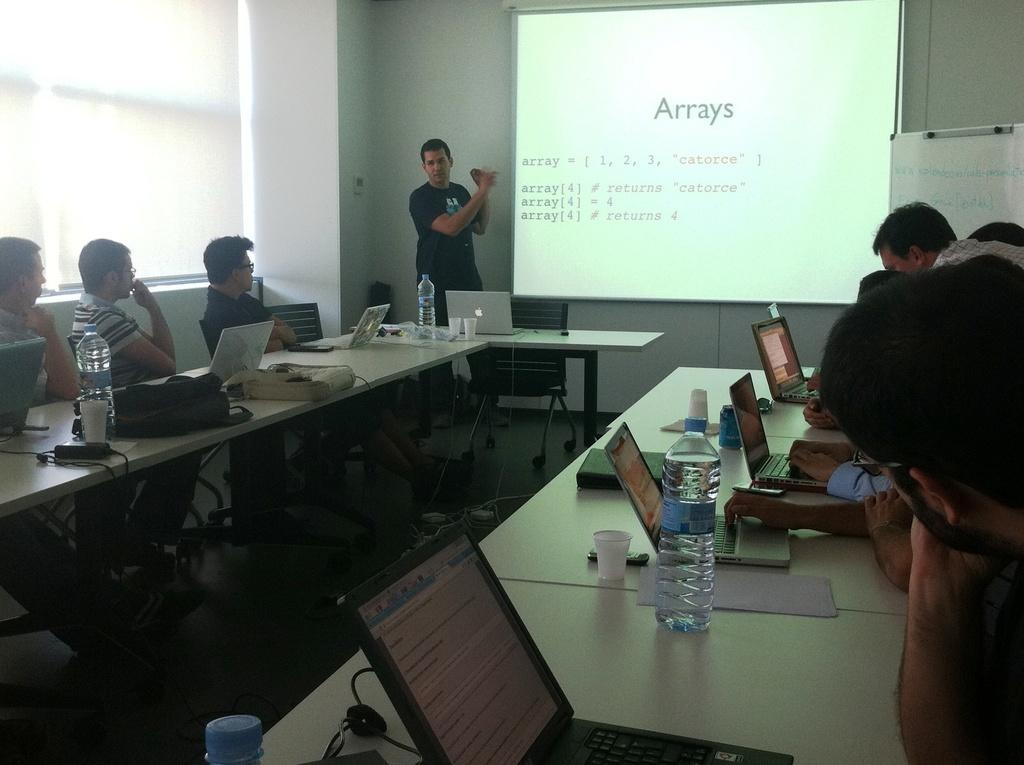<image>
Summarize the visual content of the image. A group of people seated around tables containing laptops while looking at a screen displaying information about Arrays. 